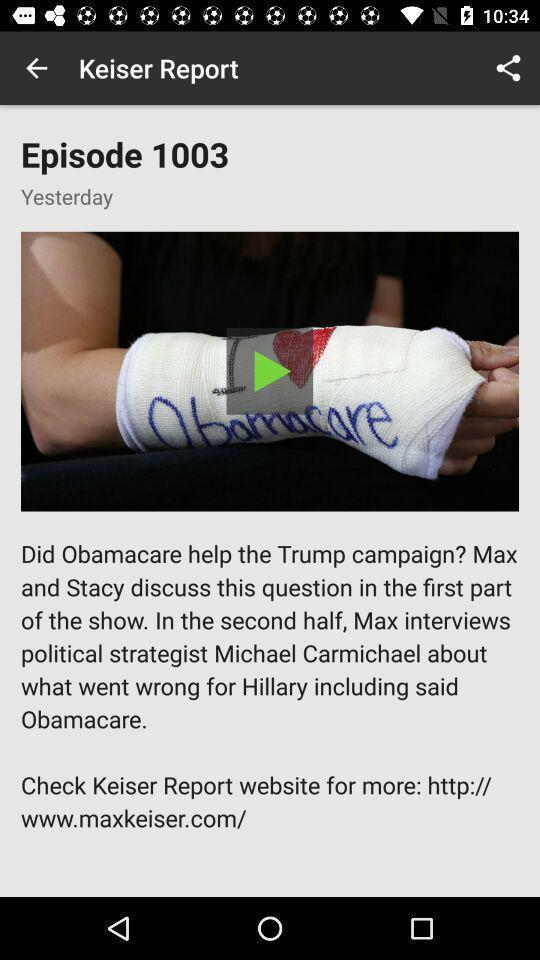Provide a detailed account of this screenshot. Page showing content in a news based app. 